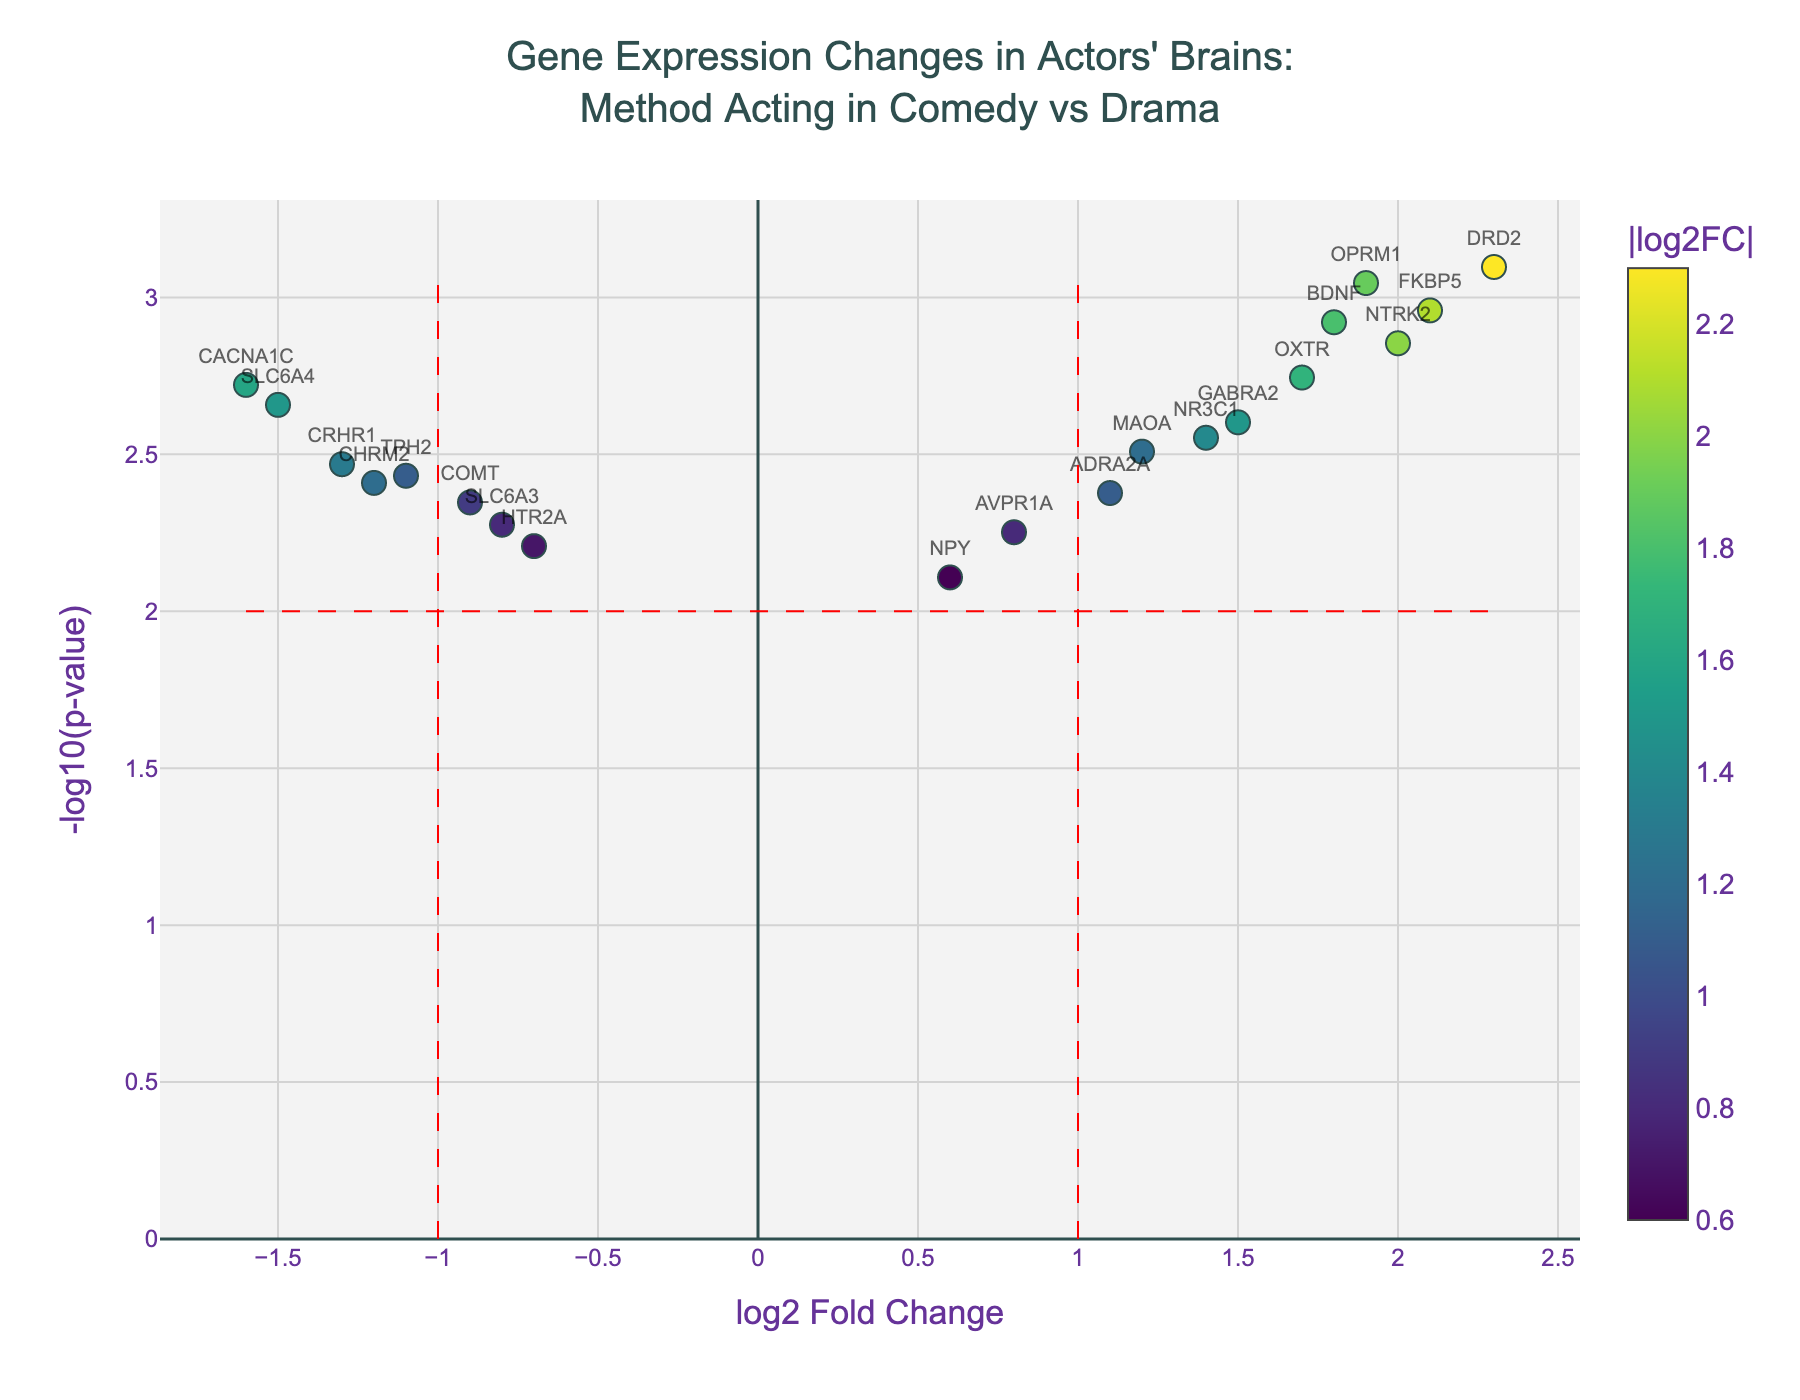What is the title of the figure? The title of the figure is located at the top center and reads: "Gene Expression Changes in Actors' Brains: Method Acting in Comedy vs Drama."
Answer: Gene Expression Changes in Actors' Brains: Method Acting in Comedy vs Drama What are the axes labels of the figure? The x-axis is labeled "log2 Fold Change," and the y-axis is labeled "-log10(p-value)."
Answer: log2 Fold Change, -log10(p-value) How many genes have a significant log2 fold change greater than 1? To determine this, look at the points to the right of the vertical red dashed line at log2FoldChange=1 and above the horizontal red dashed line at -log10(p-value)=2.
Answer: 7 Which gene has the highest -log10(p-value)? Locate the point with the highest value on the y-axis and identify the corresponding gene from the hover text or labels.
Answer: DRD2 How many genes have both a significant fold change (log2FC) and a significant p-value (-log10(p-value))? Identify genes that fall outside the vertical thresholds (greater than 1 or less than -1 in log2FoldChange) and above the horizontal threshold (-log10(p-value) > 2).
Answer: 12 Which genes display a significant downregulation? Downregulated genes will have negative log2FoldChange values and lie to the left of the vertical red dashed line at log2FoldChange=-1 and above the horizontal dashed line at -log10(p-value)=2.
Answer: COMT, SLC6A4, TPH2, CRHR1, CACNA1C What is the threshold used for significance in -log10(p-value)? The horizontal red dashed line represents the significance threshold in -log10(p-value).
Answer: 2 Which gene is indicated by the data point at log2FoldChange of 2.1 and a p-value of 0.0011? Locate the point on the plot where log2FoldChange is 2.1 and the -log10(p-value) is approximately 2.96, and identify the gene from its label or hover text.
Answer: FKBP5 What is the color scale based on in the plot? The color of the data points varies based on the absolute value of the log2FoldChange, as indicated by the color bar on the right.
Answer: Absolute value of log2FoldChange Compare the significance of OXTR and AVPR1A in terms of p-value. Which one is more significant? Compare the positions on the y-axis for OXTR and AVPR1A; higher -log10(p-value) values indicate lower p-values and thus greater significance. OXTR is located higher on the y-axis than AVPR1A.
Answer: OXTR 